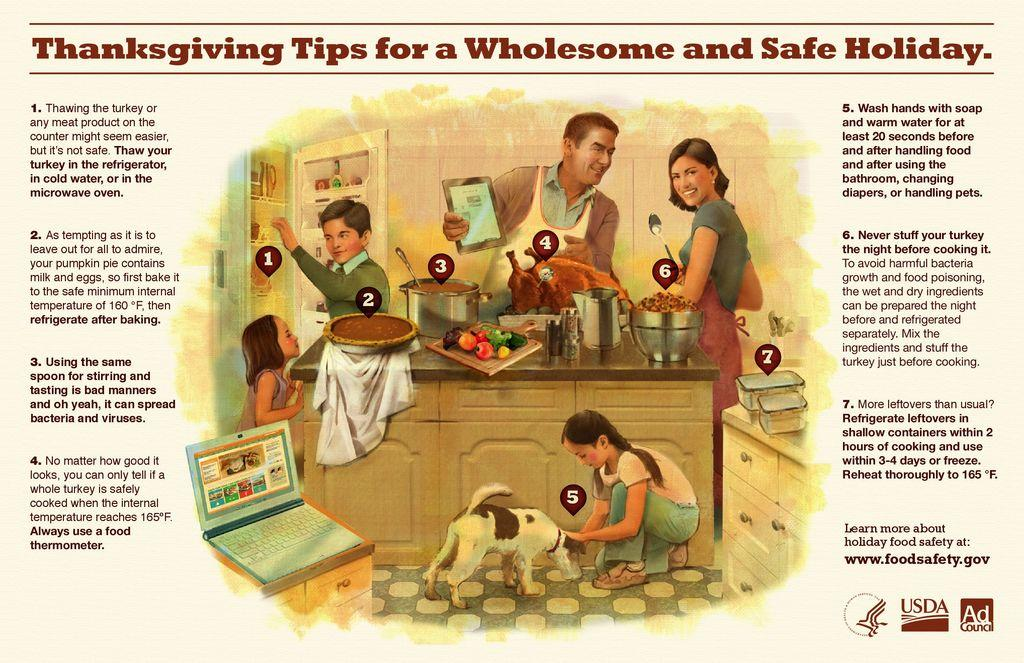<image>
Share a concise interpretation of the image provided. A Thanksgiving tips for a wholesome and safe family advertisement from the Ad Council. 